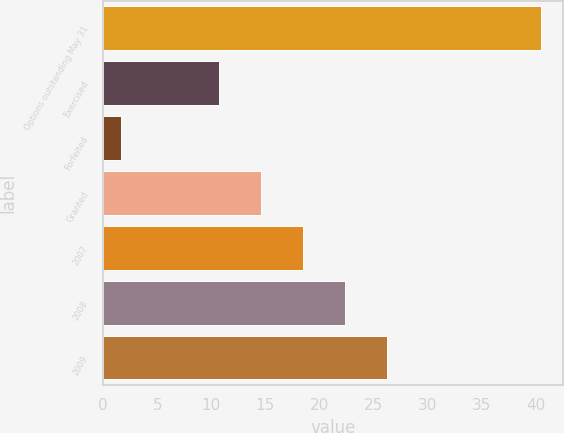Convert chart. <chart><loc_0><loc_0><loc_500><loc_500><bar_chart><fcel>Options outstanding May 31<fcel>Exercised<fcel>Forfeited<fcel>Granted<fcel>2007<fcel>2008<fcel>2009<nl><fcel>40.48<fcel>10.7<fcel>1.6<fcel>14.58<fcel>18.46<fcel>22.34<fcel>26.22<nl></chart> 